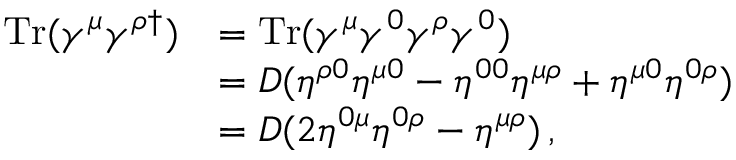Convert formula to latex. <formula><loc_0><loc_0><loc_500><loc_500>\begin{array} { r l } { T r ( \gamma ^ { \mu } \gamma ^ { \rho \dagger } ) } & { = T r ( \gamma ^ { \mu } \gamma ^ { 0 } \gamma ^ { \rho } \gamma ^ { 0 } ) } \\ & { = D ( \eta ^ { \rho 0 } \eta ^ { \mu 0 } - \eta ^ { 0 0 } \eta ^ { \mu \rho } + \eta ^ { \mu 0 } \eta ^ { 0 \rho } ) } \\ & { = D ( 2 \eta ^ { 0 \mu } \eta ^ { 0 \rho } - \eta ^ { \mu \rho } ) \, , } \end{array}</formula> 